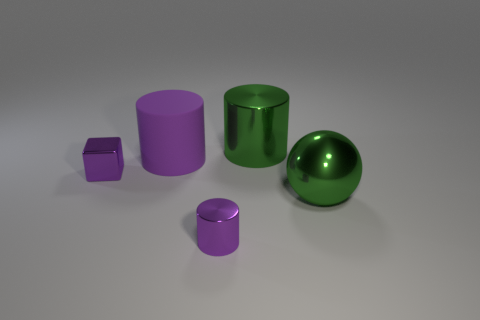Subtract all brown balls. How many purple cylinders are left? 2 Subtract all large green metallic cylinders. How many cylinders are left? 2 Add 5 small balls. How many objects exist? 10 Subtract all balls. How many objects are left? 4 Add 2 small purple shiny things. How many small purple shiny things are left? 4 Add 4 green objects. How many green objects exist? 6 Subtract 0 yellow cylinders. How many objects are left? 5 Subtract all large blue cylinders. Subtract all green objects. How many objects are left? 3 